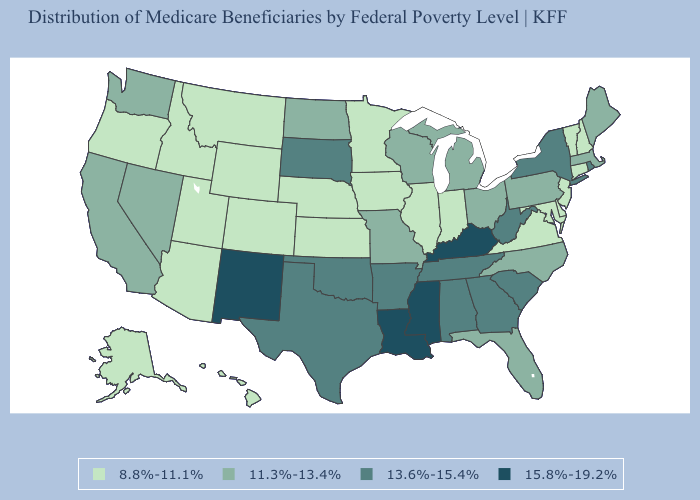What is the value of South Dakota?
Be succinct. 13.6%-15.4%. Name the states that have a value in the range 11.3%-13.4%?
Answer briefly. California, Florida, Maine, Massachusetts, Michigan, Missouri, Nevada, North Carolina, North Dakota, Ohio, Pennsylvania, Washington, Wisconsin. How many symbols are there in the legend?
Give a very brief answer. 4. Which states have the lowest value in the USA?
Keep it brief. Alaska, Arizona, Colorado, Connecticut, Delaware, Hawaii, Idaho, Illinois, Indiana, Iowa, Kansas, Maryland, Minnesota, Montana, Nebraska, New Hampshire, New Jersey, Oregon, Utah, Vermont, Virginia, Wyoming. Which states have the lowest value in the West?
Keep it brief. Alaska, Arizona, Colorado, Hawaii, Idaho, Montana, Oregon, Utah, Wyoming. Which states have the highest value in the USA?
Write a very short answer. Kentucky, Louisiana, Mississippi, New Mexico. Name the states that have a value in the range 8.8%-11.1%?
Quick response, please. Alaska, Arizona, Colorado, Connecticut, Delaware, Hawaii, Idaho, Illinois, Indiana, Iowa, Kansas, Maryland, Minnesota, Montana, Nebraska, New Hampshire, New Jersey, Oregon, Utah, Vermont, Virginia, Wyoming. Name the states that have a value in the range 11.3%-13.4%?
Short answer required. California, Florida, Maine, Massachusetts, Michigan, Missouri, Nevada, North Carolina, North Dakota, Ohio, Pennsylvania, Washington, Wisconsin. Does South Carolina have a lower value than North Dakota?
Answer briefly. No. Does Ohio have the same value as New Hampshire?
Be succinct. No. Does the first symbol in the legend represent the smallest category?
Be succinct. Yes. What is the value of New Mexico?
Keep it brief. 15.8%-19.2%. Does Connecticut have a higher value than Idaho?
Concise answer only. No. Name the states that have a value in the range 11.3%-13.4%?
Short answer required. California, Florida, Maine, Massachusetts, Michigan, Missouri, Nevada, North Carolina, North Dakota, Ohio, Pennsylvania, Washington, Wisconsin. Name the states that have a value in the range 15.8%-19.2%?
Give a very brief answer. Kentucky, Louisiana, Mississippi, New Mexico. 